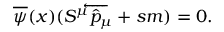Convert formula to latex. <formula><loc_0><loc_0><loc_500><loc_500>\overline { \psi } ( x ) ( S ^ { \mu } \overleftarrow { { \hat { p } } _ { \mu } } + s m ) = 0 .</formula> 